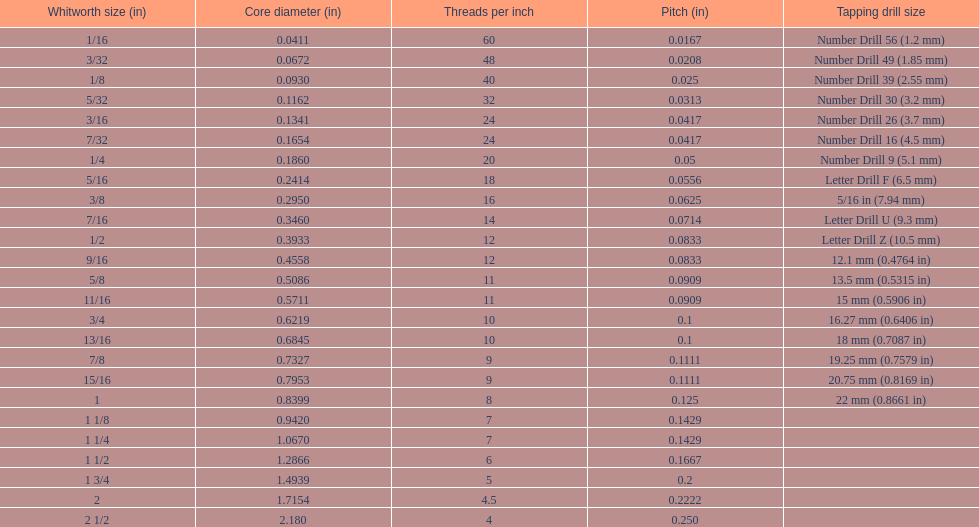What core diameter (in) comes after 0.0930? 0.1162. 